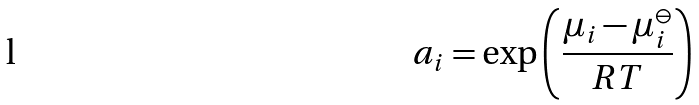Convert formula to latex. <formula><loc_0><loc_0><loc_500><loc_500>a _ { i } = \exp \left ( { \frac { \mu _ { i } - \mu _ { i } ^ { \ominus } } { R T } } \right )</formula> 